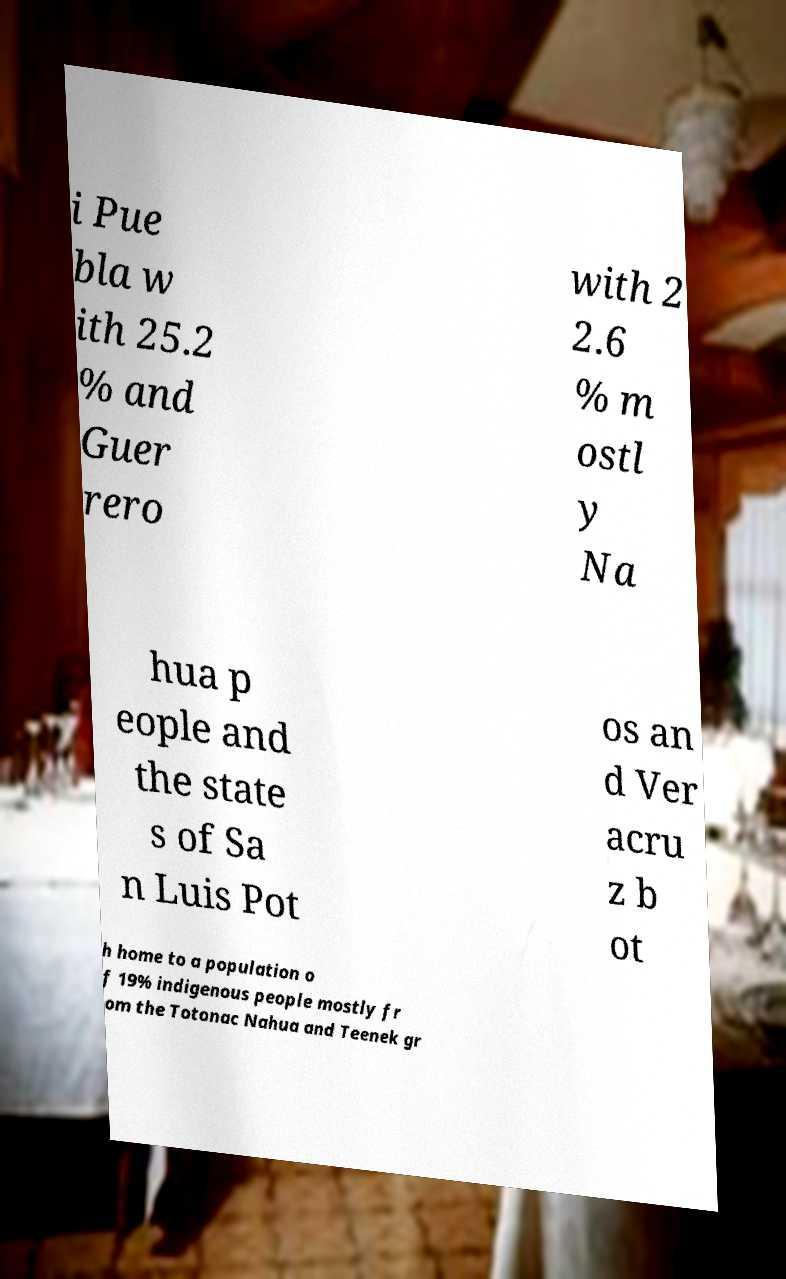I need the written content from this picture converted into text. Can you do that? i Pue bla w ith 25.2 % and Guer rero with 2 2.6 % m ostl y Na hua p eople and the state s of Sa n Luis Pot os an d Ver acru z b ot h home to a population o f 19% indigenous people mostly fr om the Totonac Nahua and Teenek gr 